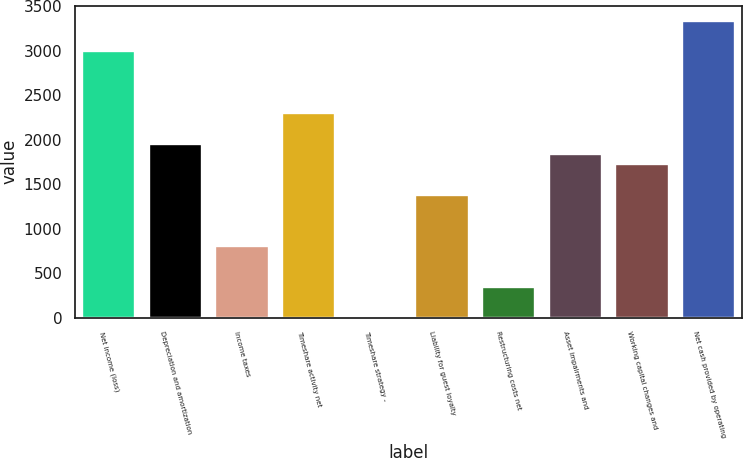<chart> <loc_0><loc_0><loc_500><loc_500><bar_chart><fcel>Net income (loss)<fcel>Depreciation and amortization<fcel>Income taxes<fcel>Timeshare activity net<fcel>Timeshare strategy -<fcel>Liability for guest loyalty<fcel>Restructuring costs net<fcel>Asset impairments and<fcel>Working capital changes and<fcel>Net cash provided by operating<nl><fcel>2992.11<fcel>1956.48<fcel>805.78<fcel>2301.69<fcel>0.29<fcel>1381.13<fcel>345.5<fcel>1841.41<fcel>1726.34<fcel>3337.32<nl></chart> 